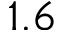<formula> <loc_0><loc_0><loc_500><loc_500>1 . 6</formula> 